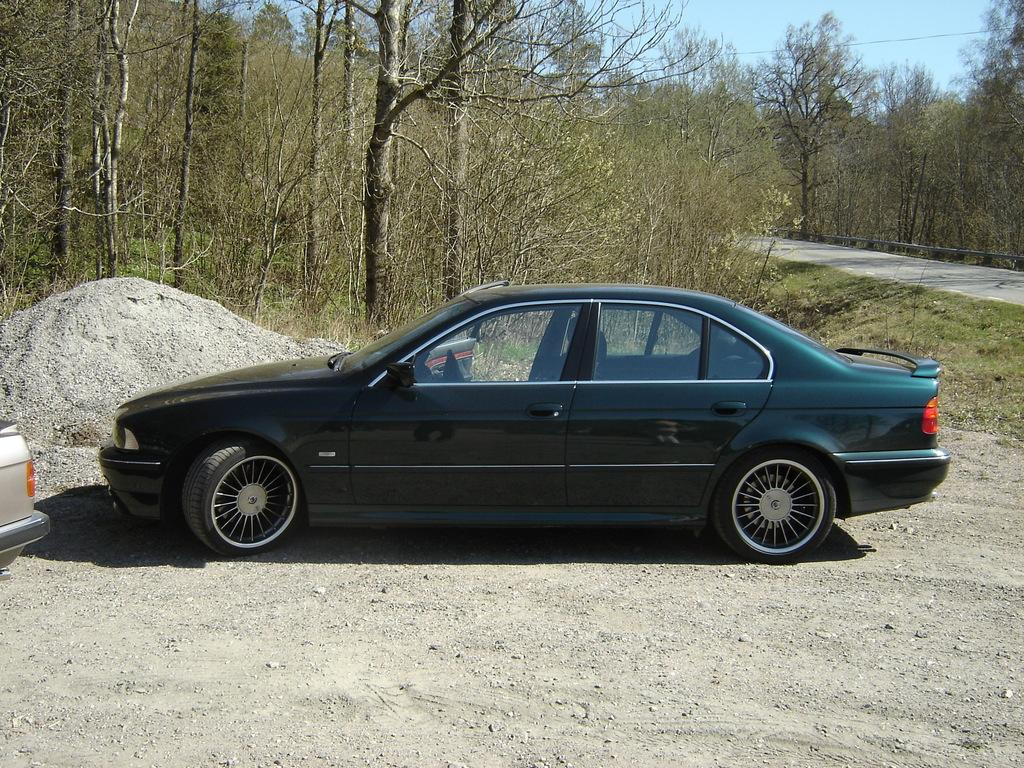What is the main subject of the image? There is a vehicle in the image. Can you describe the colors of the vehicle? The vehicle has black and green colors. What can be seen in the background of the image? There are trees in the background of the image. What is the color of the trees? The trees are green. What color is the sky in the image? The sky is blue in the image. How many arms are visible on the vehicle in the image? There are no arms visible on the vehicle in the image, as vehicles do not have arms. 